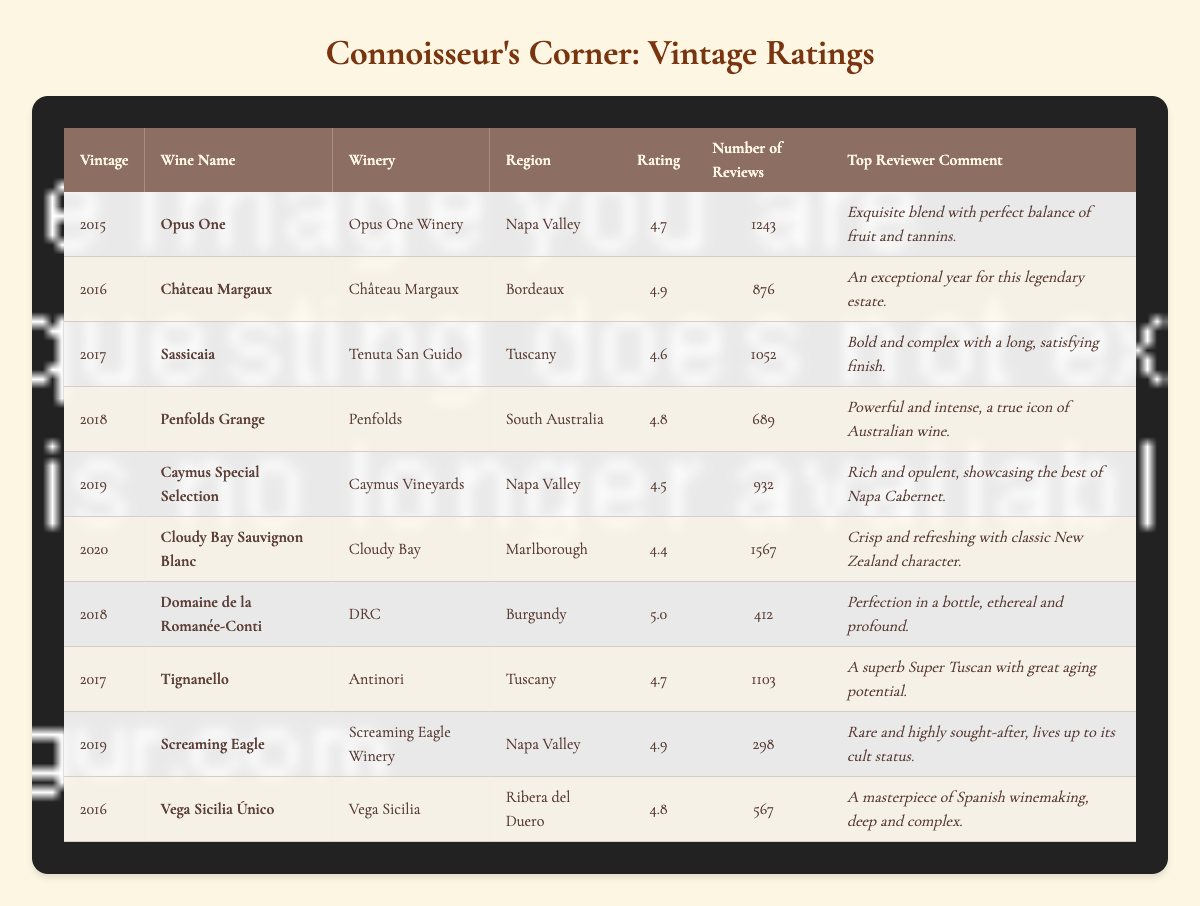What is the highest rating among the wines listed? The highest rating from the table is found by comparing the "Rating" column. The ratings are 4.7, 4.9, 4.6, 4.8, 4.5, 4.4, 5.0, 4.7, 4.9, and 4.8. The maximum value here is 5.0.
Answer: 5.0 Which wine has the most reviews? To determine which wine has the most reviews, look at the "Number of Reviews" column. The values are 1243, 876, 1052, 689, 932, 1567, 412, 1103, 298, and 567. The highest value is 1567, associated with "Cloudy Bay Sauvignon Blanc."
Answer: Cloudy Bay Sauvignon Blanc How many vintages received a rating of 4.7 or higher? By examining the "Rating" column, the ratings equal to or above 4.7 are 4.7, 4.9, 4.8, 5.0, 4.7, and 4.9. There are 6 vintages meeting this condition, counted individually.
Answer: 6 Is the wine "Screaming Eagle" from Napa Valley rated higher than "Opus One"? To answer this, we find the ratings for both wines. "Screaming Eagle" has a rating of 4.9 and "Opus One" has a rating of 4.7. Since 4.9 is greater than 4.7, it indeed is rated higher.
Answer: Yes What is the average rating of the wines from Napa Valley? The Napa Valley wines are "Opus One" (4.7), "Caymus Special Selection" (4.5), and "Screaming Eagle" (4.9). We calculate the average by summing these ratings (4.7 + 4.5 + 4.9 = 14.1) and dividing by 3, which gives us 14.1 / 3 = 4.7.
Answer: 4.7 Which wine from Tuscany has the highest rating and how much is it? The wines from Tuscany listed are "Sassicaia" (4.6) and "Tignanello" (4.7). Comparing these ratings, "Tignanello" has the higher rating of 4.7.
Answer: Tignanello, 4.7 How many wines have a rating above 4.5 and also had more than 800 reviews? The wines that satisfy both conditions are "Opus One" (1243 reviews, 4.7), "Château Margaux" (876 reviews, 4.9), "Sassicaia" (1052 reviews, 4.6), "Penfolds Grange" (689 reviews, 4.8), "Caymus Special Selection" (932 reviews, 4.5), and "Vega Sicilia Único" (567 reviews, 4.8). Only "Opus One," "Château Margaux," "Sassicaia," and "Caymus Special Selection" qualify since they have ratings above 4.5 and reviews above 800. Thus, there are 4 wines.
Answer: 4 Is it true that the wine with the least number of reviews has the highest rating? The wine with the least number of reviews is "Screaming Eagle" with 298 reviews and a rating of 4.9. While it has a high rating, we check the other ratings corresponding to the number of reviews. The highest rating overall is 5.0, associated with "Domaine de la Romanée-Conti," which has 412 reviews. Thus, it is false that the wine with the least number of reviews has the highest rating.
Answer: No Which wine vintage is rated the lowest, and what is its rating? Checking the "Rating" column for the lowest value, we see that "Cloudy Bay Sauvignon Blanc" has the lowest rating of 4.4.
Answer: Cloudy Bay Sauvignon Blanc, 4.4 How much more is the rating of "Domaine de la Romanée-Conti" compared to "Angus Gold"? Since "Angus Gold" is not listed in the table, we cannot provide a difference. Thus, by logical deduction, the question contains a false premise. However, we can state that the rating for "Domaine de la Romanée-Conti" is 5.0.
Answer: Not applicable 